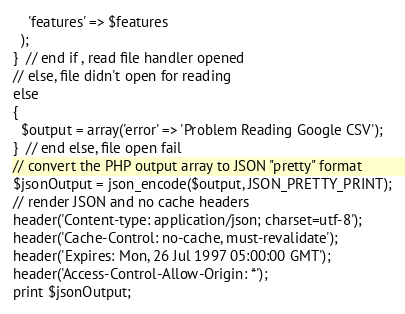<code> <loc_0><loc_0><loc_500><loc_500><_PHP_>    'features' => $features
  );
}  // end if , read file handler opened
// else, file didn't open for reading
else
{
  $output = array('error' => 'Problem Reading Google CSV');
}  // end else, file open fail
// convert the PHP output array to JSON "pretty" format
$jsonOutput = json_encode($output, JSON_PRETTY_PRINT);
// render JSON and no cache headers
header('Content-type: application/json; charset=utf-8');
header('Cache-Control: no-cache, must-revalidate');
header('Expires: Mon, 26 Jul 1997 05:00:00 GMT');
header('Access-Control-Allow-Origin: *');
print $jsonOutput;</code> 